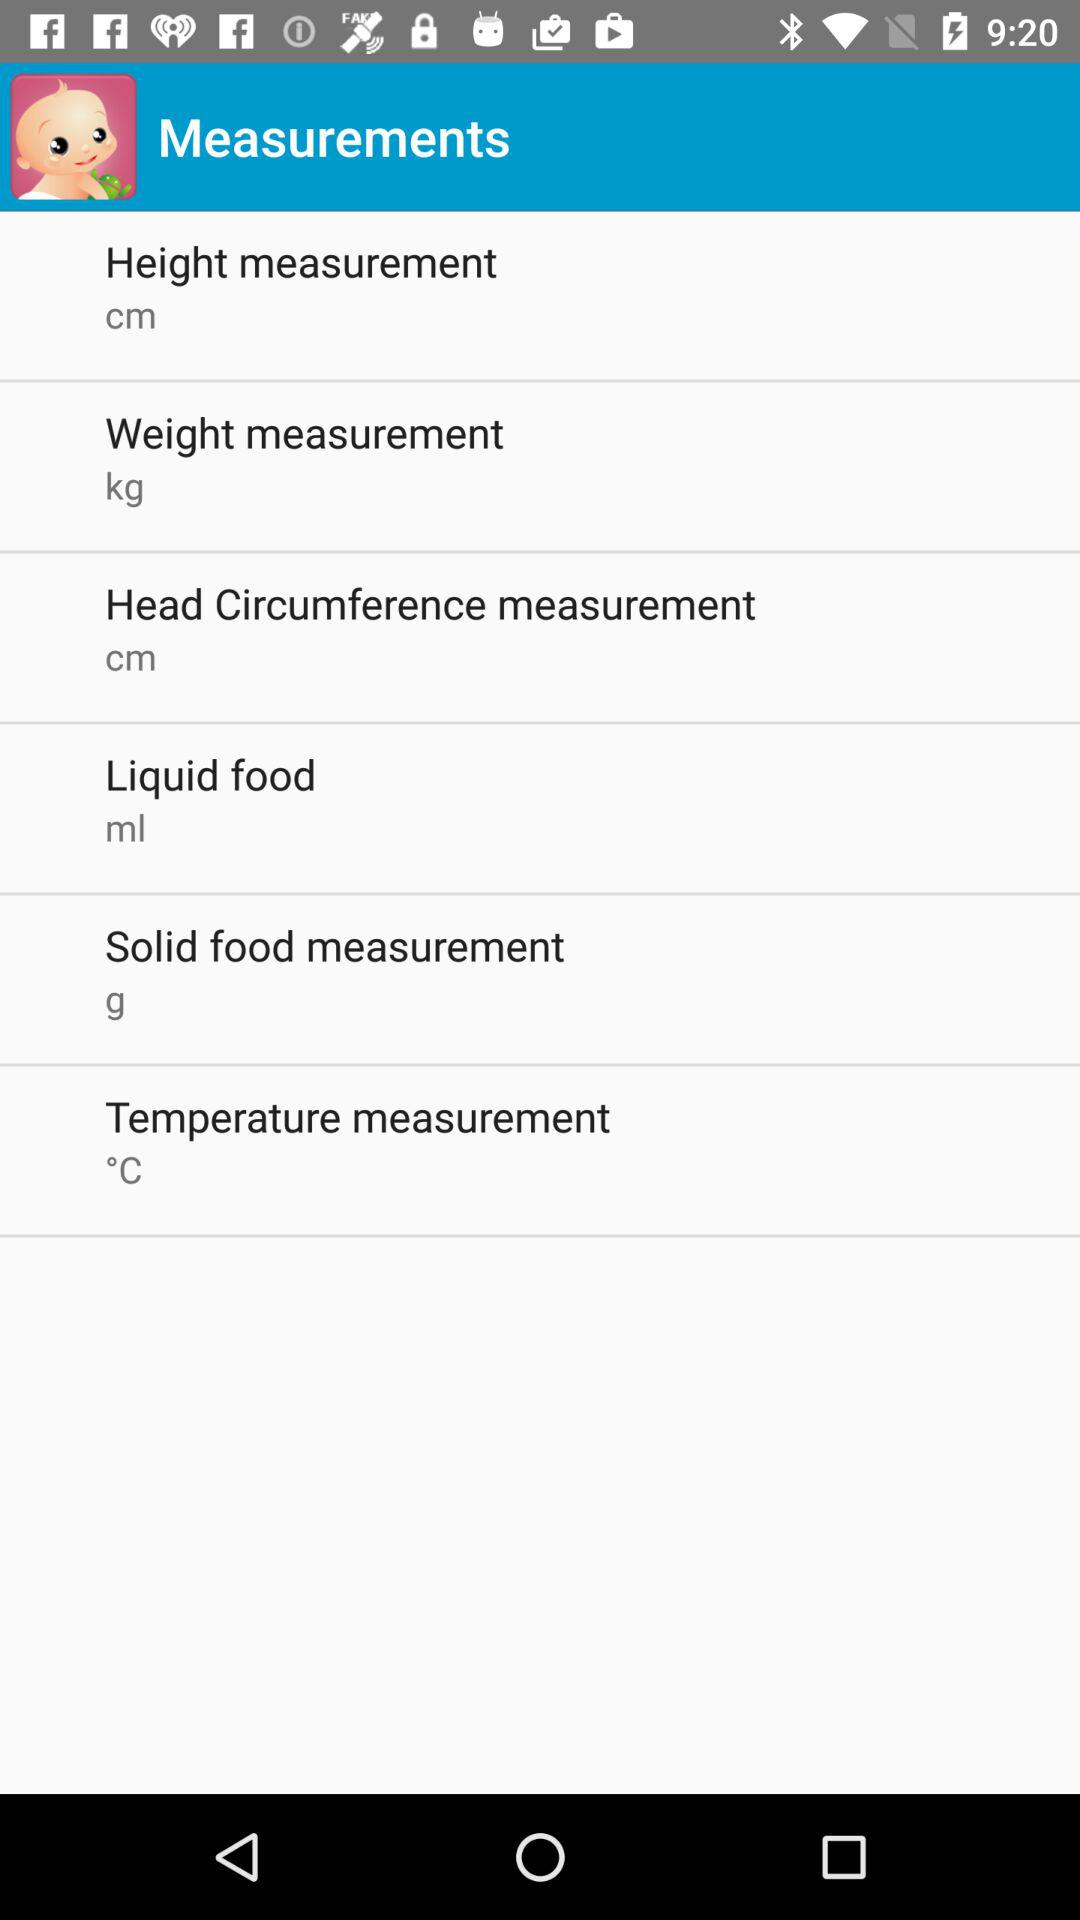What is measured in grams? You can take "Solid food measurement" in grams. 